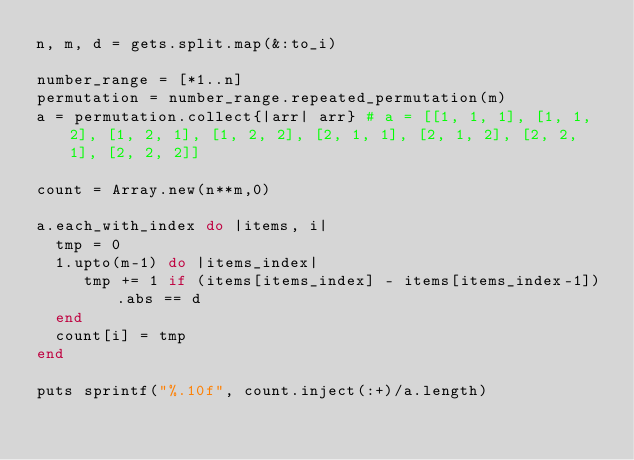<code> <loc_0><loc_0><loc_500><loc_500><_Ruby_>n, m, d = gets.split.map(&:to_i)

number_range = [*1..n]
permutation = number_range.repeated_permutation(m)
a = permutation.collect{|arr| arr} # a = [[1, 1, 1], [1, 1, 2], [1, 2, 1], [1, 2, 2], [2, 1, 1], [2, 1, 2], [2, 2, 1], [2, 2, 2]]

count = Array.new(n**m,0)

a.each_with_index do |items, i|
  tmp = 0
  1.upto(m-1) do |items_index|
     tmp += 1 if (items[items_index] - items[items_index-1]).abs == d
  end
  count[i] = tmp
end

puts sprintf("%.10f", count.inject(:+)/a.length)</code> 